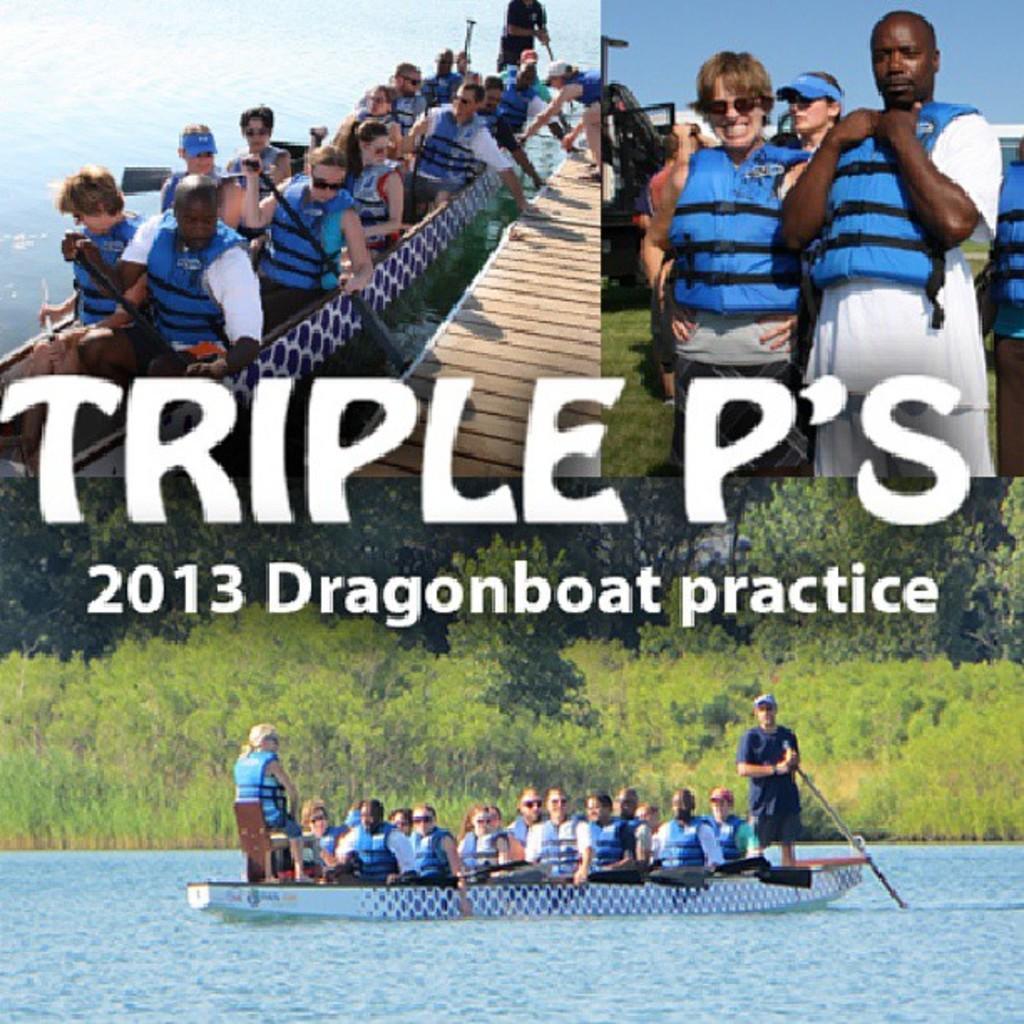Describe this image in one or two sentences. In the image we can see there are three pictures. In the left corner picture we can see there are people sitting in the boat and they are wearing a water jacket. In the right top we can see there are people standing, wearing clothes and some people are wearing goggles, and in the bottom image we can see there are many trees, this is a text. 